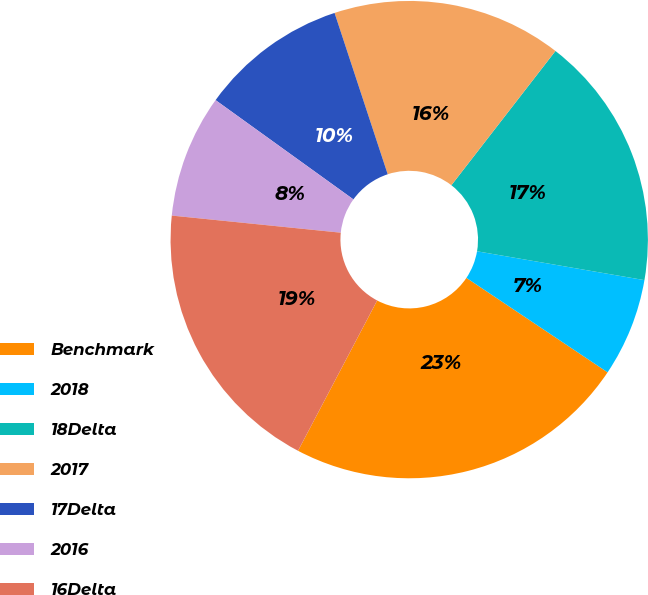Convert chart. <chart><loc_0><loc_0><loc_500><loc_500><pie_chart><fcel>Benchmark<fcel>2018<fcel>18Delta<fcel>2017<fcel>17Delta<fcel>2016<fcel>16Delta<nl><fcel>23.33%<fcel>6.67%<fcel>17.22%<fcel>15.56%<fcel>10.0%<fcel>8.33%<fcel>18.89%<nl></chart> 